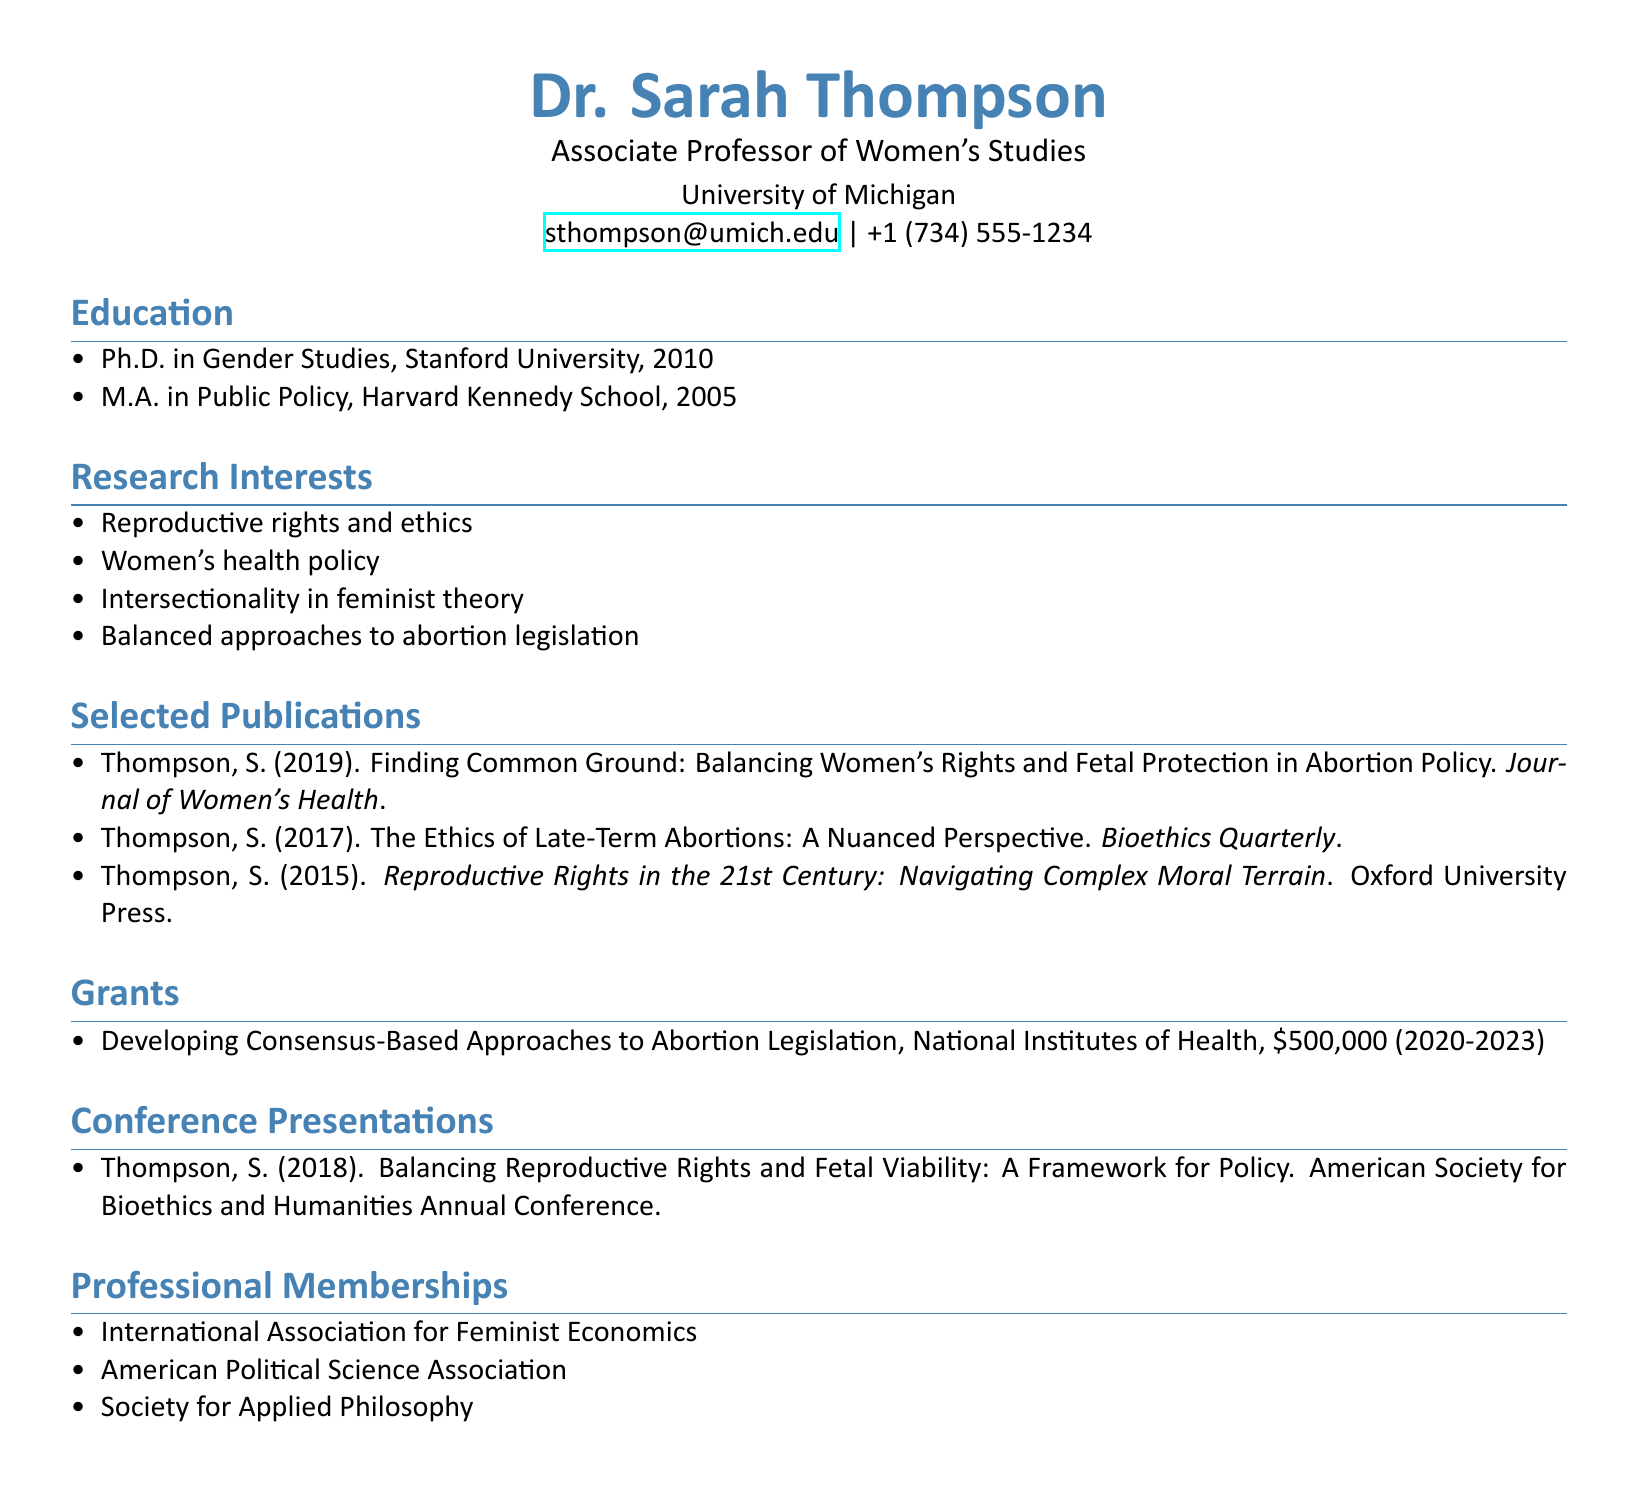What is Dr. Sarah Thompson's title? The title listed in the document is her professional title.
Answer: Associate Professor of Women's Studies Which university is Dr. Thompson affiliated with? The document states the university where she works.
Answer: University of Michigan What year did Dr. Thompson earn her Ph.D.? The education section provides the year she completed her doctoral degree.
Answer: 2010 What is the title of Dr. Thompson's publication in the Journal of Women's Health? This is a specific title found in the list of selected publications.
Answer: Finding Common Ground: Balancing Women's Rights and Fetal Protection in Abortion Policy How much funding did Dr. Thompson receive for her grant? The grant section indicates the amount of funding provided for her research.
Answer: $500,000 What is the focus of Dr. Thompson's research interests? This question requires synthesizing information on her areas of expertise in the document.
Answer: Reproductive rights and ethics In which year did Dr. Thompson present at the American Society for Bioethics and Humanities Annual Conference? The conference presentations section specifies the year of her presentation.
Answer: 2018 What type of publication is "Reproductive Rights in the 21st Century"? The document indicates the type of the publication in its selected publications section.
Answer: Book How many professional memberships does Dr. Thompson have listed? A count of the organizations in her professional memberships section indicates the number.
Answer: 3 